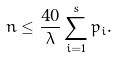Convert formula to latex. <formula><loc_0><loc_0><loc_500><loc_500>n \leq \frac { 4 0 } { \lambda } \sum _ { i = 1 } ^ { s } p _ { i } .</formula> 